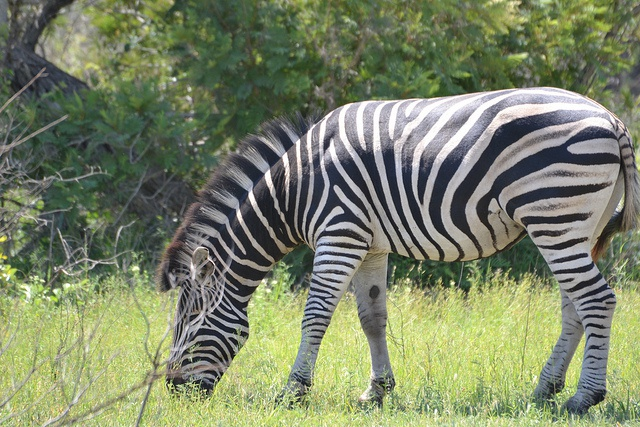Describe the objects in this image and their specific colors. I can see a zebra in gray, darkgray, black, and lightgray tones in this image. 